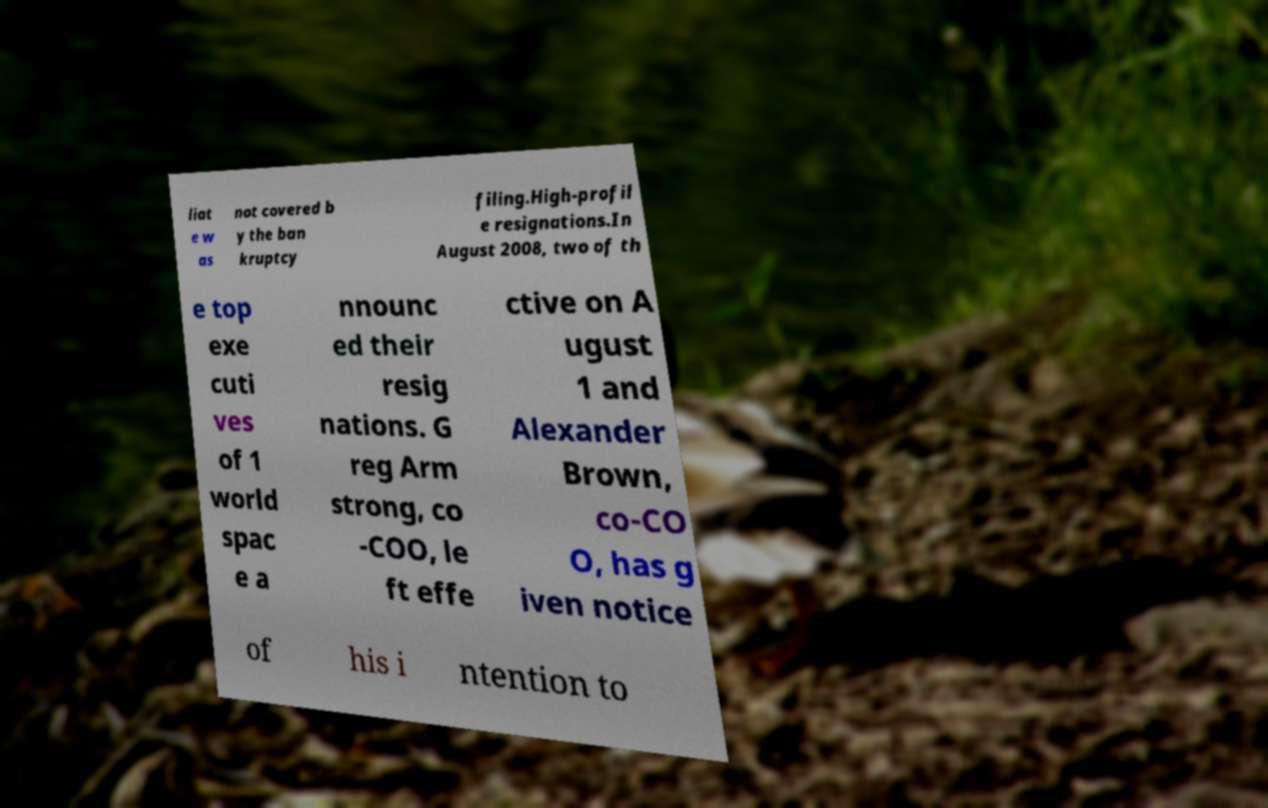What messages or text are displayed in this image? I need them in a readable, typed format. liat e w as not covered b y the ban kruptcy filing.High-profil e resignations.In August 2008, two of th e top exe cuti ves of 1 world spac e a nnounc ed their resig nations. G reg Arm strong, co -COO, le ft effe ctive on A ugust 1 and Alexander Brown, co-CO O, has g iven notice of his i ntention to 